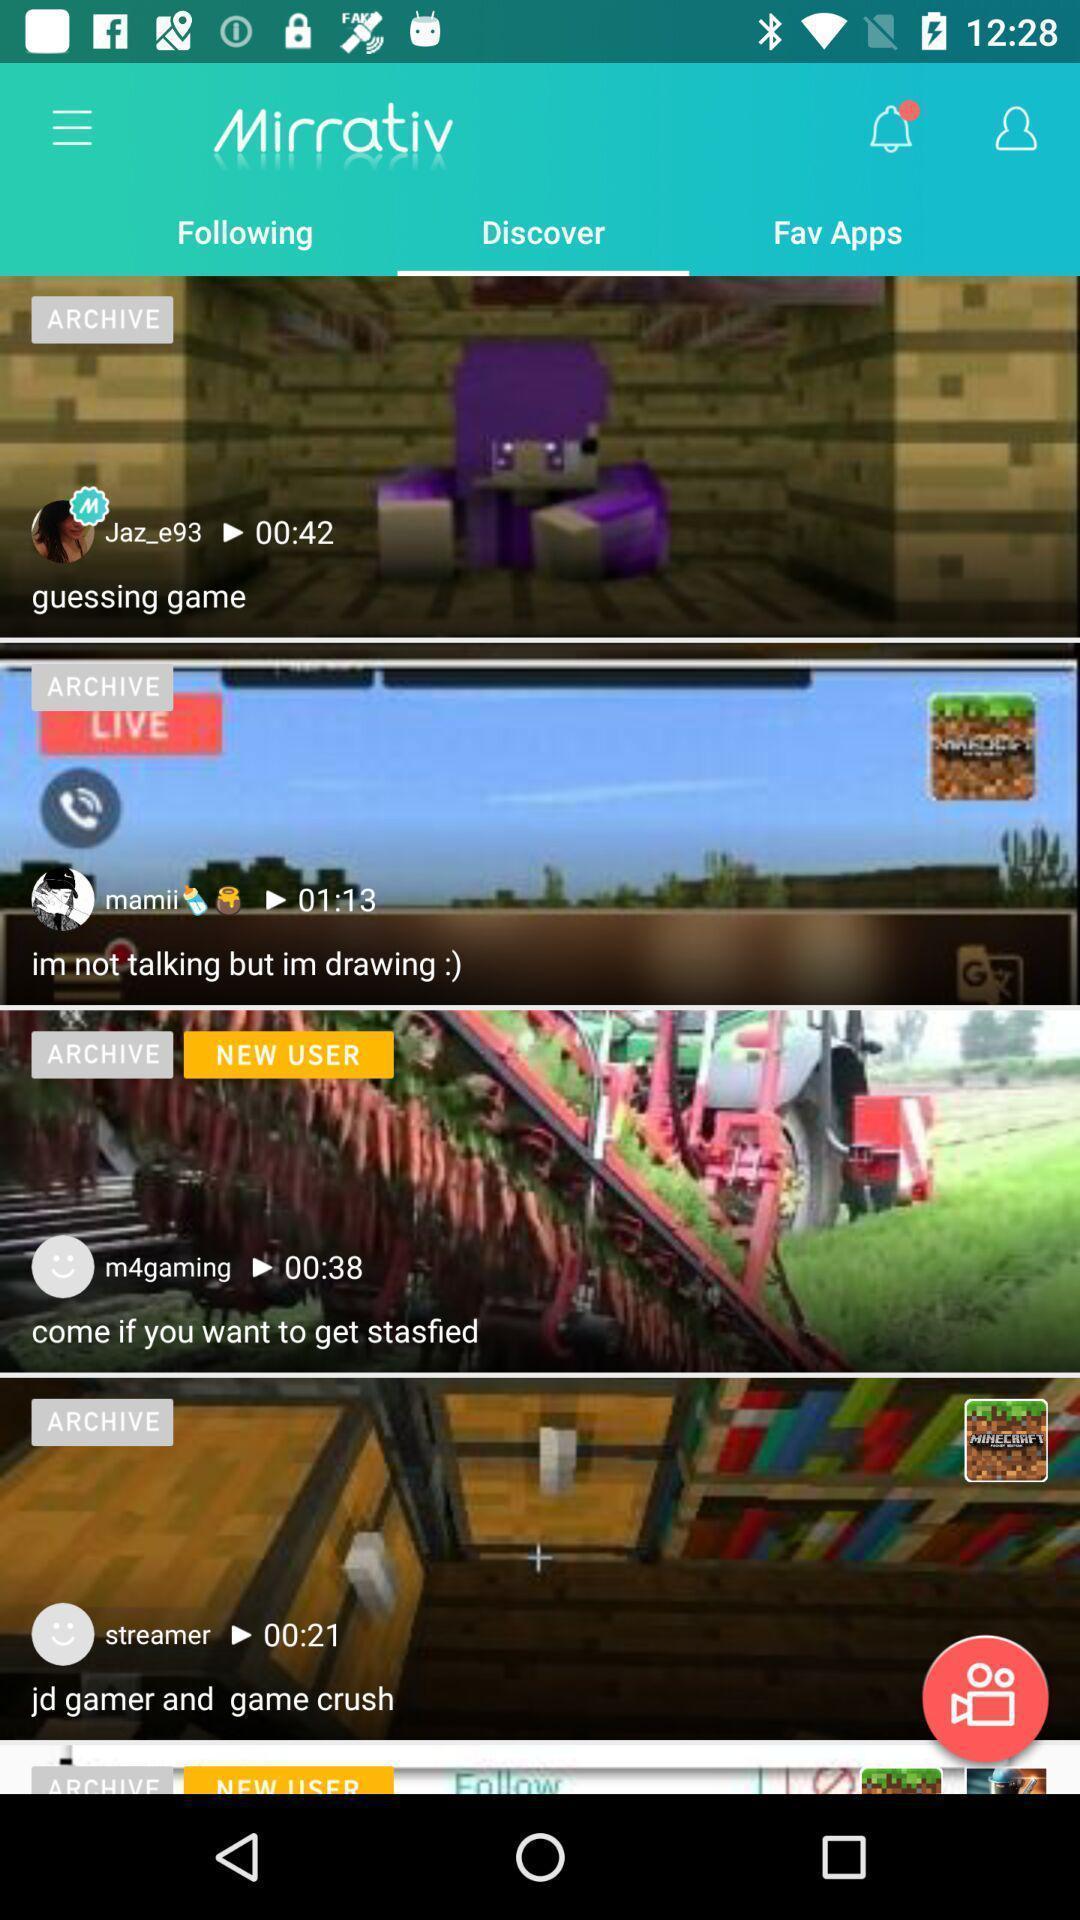Provide a textual representation of this image. Screen displaying the discover page. 